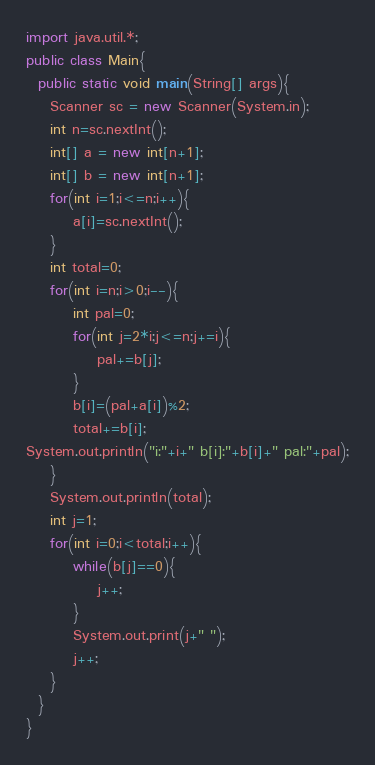Convert code to text. <code><loc_0><loc_0><loc_500><loc_500><_Java_>import java.util.*;
public class Main{
  public static void main(String[] args){
    Scanner sc = new Scanner(System.in);
    int n=sc.nextInt();
    int[] a = new int[n+1];
    int[] b = new int[n+1];
    for(int i=1;i<=n;i++){
        a[i]=sc.nextInt();
    }
    int total=0;
    for(int i=n;i>0;i--){
        int pal=0;
        for(int j=2*i;j<=n;j+=i){
            pal+=b[j];
        }
        b[i]=(pal+a[i])%2;
        total+=b[i];
System.out.println("i:"+i+" b[i]:"+b[i]+" pal:"+pal);
    }
    System.out.println(total);
    int j=1;
    for(int i=0;i<total;i++){
        while(b[j]==0){
            j++;
        }
        System.out.print(j+" ");
        j++;
    }
  }
}

</code> 